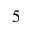<formula> <loc_0><loc_0><loc_500><loc_500>5</formula> 